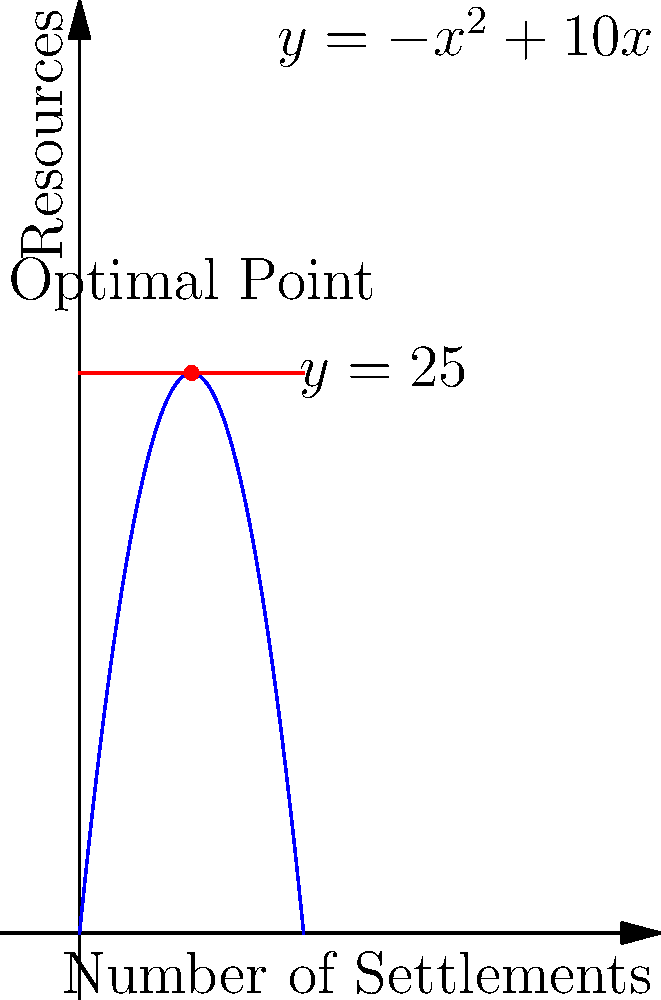During the Dark Ages, a regional governor must distribute resources among settlements. The resource distribution function is given by $R(x) = -x^2 + 10x$, where $x$ is the number of settlements and $R(x)$ is the total resources distributed. If the maximum available resources are 25 units, determine the optimal number of settlements to maximize resource distribution while not exceeding the available resources. To solve this optimization problem, we need to follow these steps:

1) The resource distribution function is $R(x) = -x^2 + 10x$, and we need to find its maximum value that does not exceed 25.

2) To find the maximum of this quadratic function, we can use calculus:
   $R'(x) = -2x + 10$
   Set $R'(x) = 0$:
   $-2x + 10 = 0$
   $x = 5$

3) This critical point ($x = 5$) gives us the vertex of the parabola, which is the maximum point of the function.

4) Let's verify if this point satisfies our constraint:
   $R(5) = -(5)^2 + 10(5) = -25 + 50 = 25$

5) Indeed, when $x = 5$, $R(x) = 25$, which is exactly our maximum available resources.

6) We can confirm this is a maximum (not a minimum) because the parabola opens downward (negative coefficient of $x^2$).

Therefore, the optimal number of settlements is 5, which will utilize all 25 units of available resources.
Answer: 5 settlements 